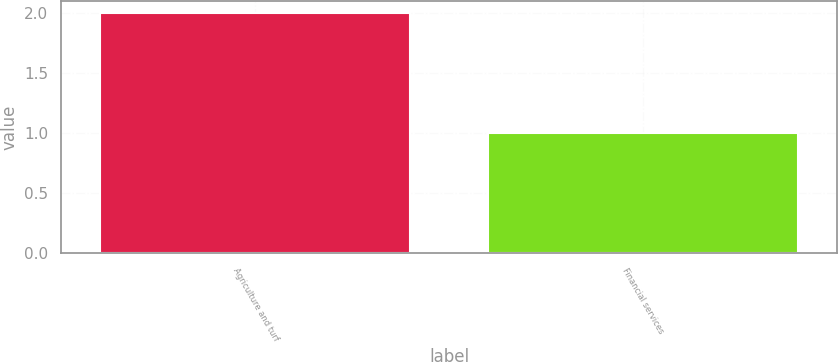<chart> <loc_0><loc_0><loc_500><loc_500><bar_chart><fcel>Agriculture and turf<fcel>Financial services<nl><fcel>2<fcel>1<nl></chart> 